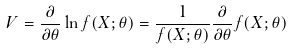<formula> <loc_0><loc_0><loc_500><loc_500>V = { \frac { \partial } { \partial \theta } } \ln f ( X ; \theta ) = { \frac { 1 } { f ( X ; \theta ) } } { \frac { \partial } { \partial \theta } } f ( X ; \theta )</formula> 